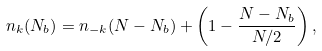Convert formula to latex. <formula><loc_0><loc_0><loc_500><loc_500>n _ { k } ( N _ { b } ) = n _ { - k } ( N - N _ { b } ) + \left ( 1 - \frac { N - N _ { b } } { N / 2 } \right ) ,</formula> 